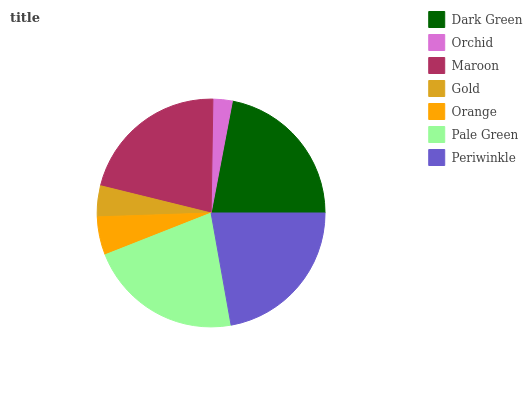Is Orchid the minimum?
Answer yes or no. Yes. Is Periwinkle the maximum?
Answer yes or no. Yes. Is Maroon the minimum?
Answer yes or no. No. Is Maroon the maximum?
Answer yes or no. No. Is Maroon greater than Orchid?
Answer yes or no. Yes. Is Orchid less than Maroon?
Answer yes or no. Yes. Is Orchid greater than Maroon?
Answer yes or no. No. Is Maroon less than Orchid?
Answer yes or no. No. Is Maroon the high median?
Answer yes or no. Yes. Is Maroon the low median?
Answer yes or no. Yes. Is Orchid the high median?
Answer yes or no. No. Is Periwinkle the low median?
Answer yes or no. No. 